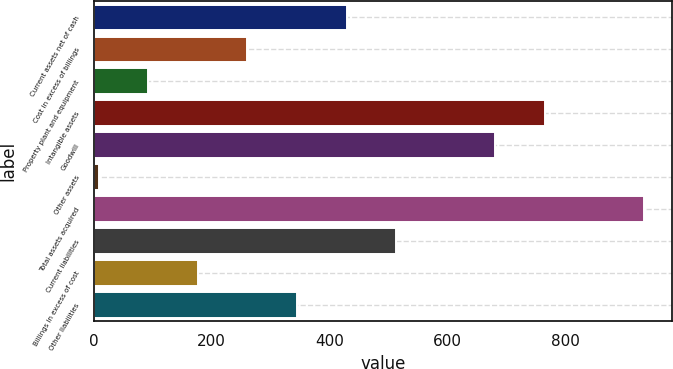<chart> <loc_0><loc_0><loc_500><loc_500><bar_chart><fcel>Current assets net of cash<fcel>Cost in excess of billings<fcel>Property plant and equipment<fcel>Intangible assets<fcel>Goodwill<fcel>Other assets<fcel>Total assets acquired<fcel>Current liabilities<fcel>Billings in excess of cost<fcel>Other liabilities<nl><fcel>429<fcel>260.6<fcel>92.2<fcel>765.8<fcel>681.6<fcel>8<fcel>934.2<fcel>513.2<fcel>176.4<fcel>344.8<nl></chart> 